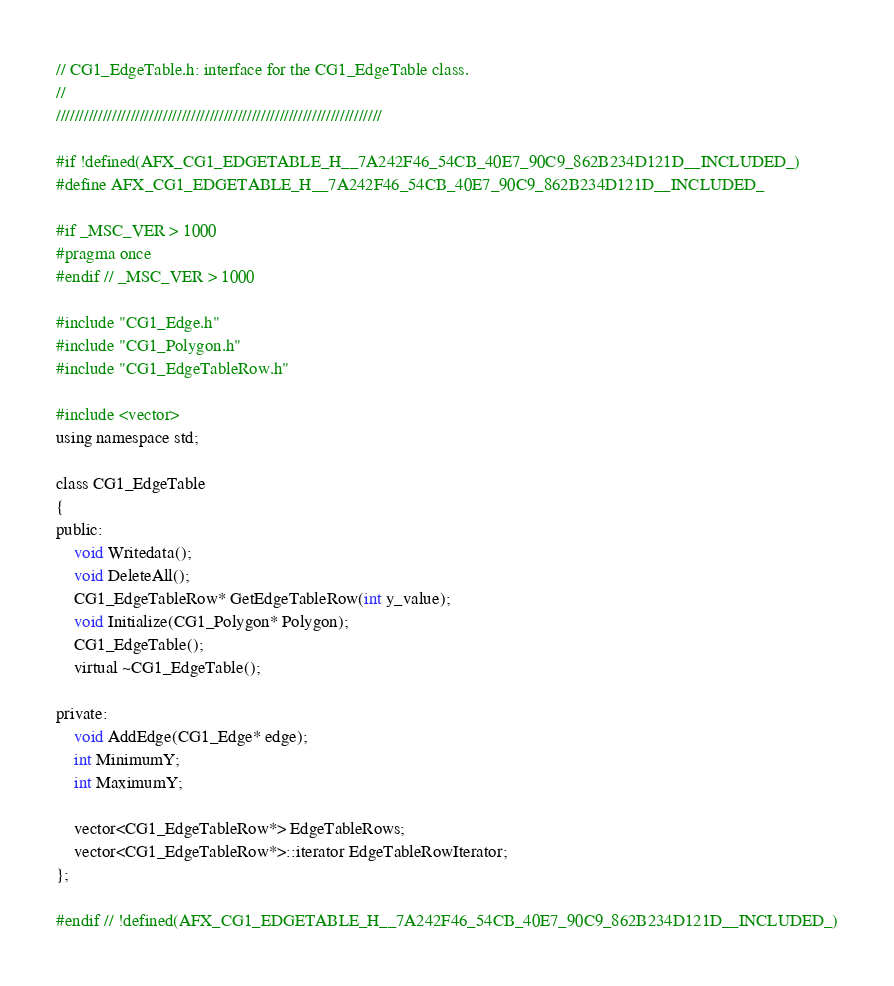Convert code to text. <code><loc_0><loc_0><loc_500><loc_500><_C_>// CG1_EdgeTable.h: interface for the CG1_EdgeTable class.
//
//////////////////////////////////////////////////////////////////////

#if !defined(AFX_CG1_EDGETABLE_H__7A242F46_54CB_40E7_90C9_862B234D121D__INCLUDED_)
#define AFX_CG1_EDGETABLE_H__7A242F46_54CB_40E7_90C9_862B234D121D__INCLUDED_

#if _MSC_VER > 1000
#pragma once
#endif // _MSC_VER > 1000

#include "CG1_Edge.h"
#include "CG1_Polygon.h"
#include "CG1_EdgeTableRow.h"

#include <vector>
using namespace std;

class CG1_EdgeTable  
{
public:
	void Writedata();
	void DeleteAll();
	CG1_EdgeTableRow* GetEdgeTableRow(int y_value);
	void Initialize(CG1_Polygon* Polygon);
	CG1_EdgeTable();
	virtual ~CG1_EdgeTable();

private:
    void AddEdge(CG1_Edge* edge);
    int MinimumY;
    int MaximumY;

    vector<CG1_EdgeTableRow*> EdgeTableRows;
    vector<CG1_EdgeTableRow*>::iterator EdgeTableRowIterator;
};

#endif // !defined(AFX_CG1_EDGETABLE_H__7A242F46_54CB_40E7_90C9_862B234D121D__INCLUDED_)
</code> 